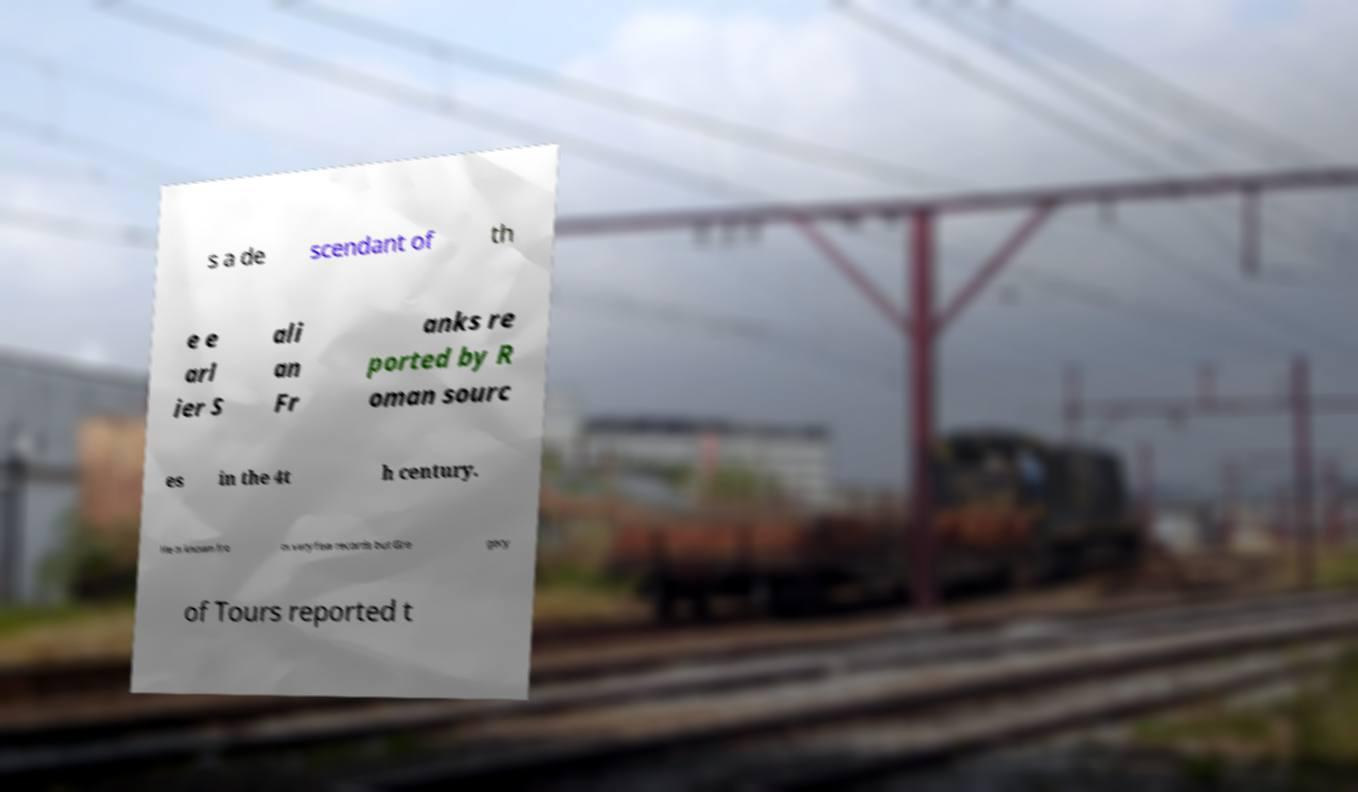Could you assist in decoding the text presented in this image and type it out clearly? s a de scendant of th e e arl ier S ali an Fr anks re ported by R oman sourc es in the 4t h century. He is known fro m very few records but Gre gory of Tours reported t 